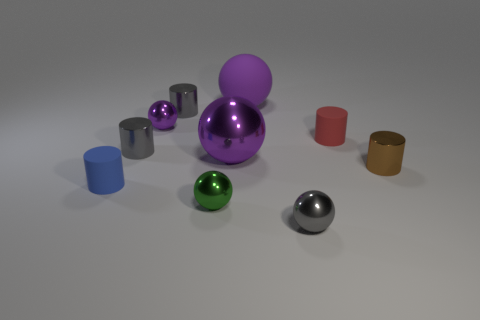There is a gray metallic thing on the right side of the tiny green shiny thing; is it the same shape as the tiny green metallic thing in front of the brown object? While the gray metallic object on the right side and the green metallic object in front of the brown cylinder are similar in sheen and reflective properties, their shapes differ. The gray metallic object is a sphere, whereas the green metallic object has a cylindrical shape. The sphere's surface curves consistently in all directions, giving it a perfect roundness, while the green cylinder has straight sides and circular ends. 